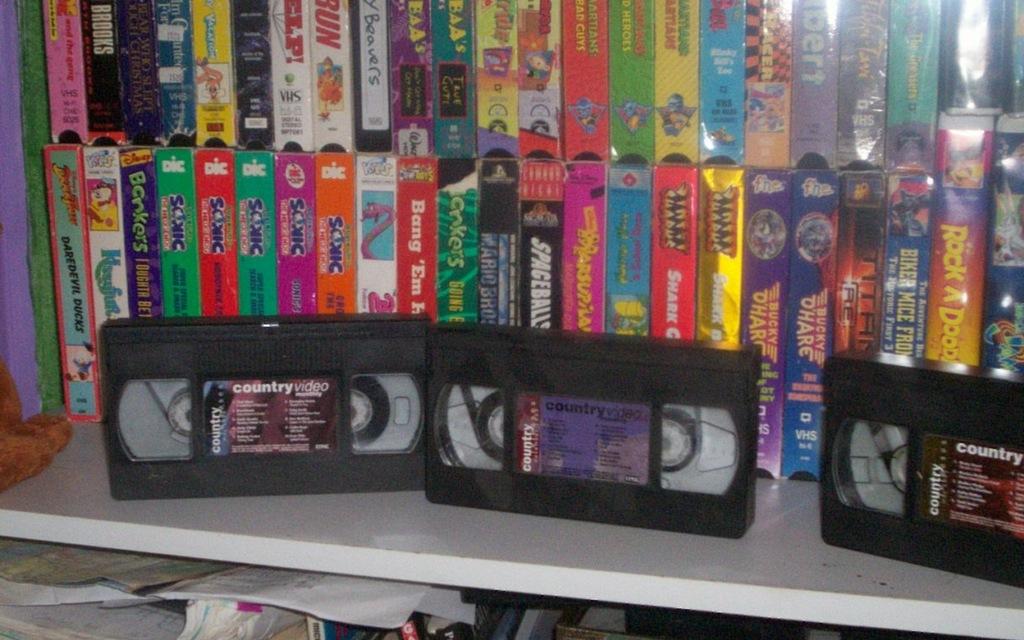What type of video is on the left?
Your answer should be very brief. Country. Boos are shown?
Provide a succinct answer. Unanswerable. 